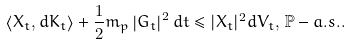Convert formula to latex. <formula><loc_0><loc_0><loc_500><loc_500>\left \langle X _ { t } , d K _ { t } \right \rangle + \frac { 1 } { 2 } m _ { p } \left | G _ { t } \right | ^ { 2 } d t \leq | X _ { t } | ^ { 2 } d V _ { t } , \, \mathbb { P } - a . s . .</formula> 